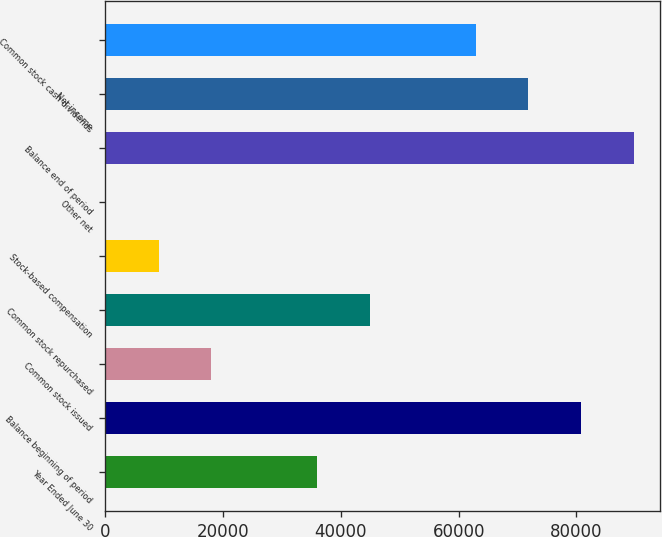Convert chart. <chart><loc_0><loc_0><loc_500><loc_500><bar_chart><fcel>Year Ended June 30<fcel>Balance beginning of period<fcel>Common stock issued<fcel>Common stock repurchased<fcel>Stock-based compensation<fcel>Other net<fcel>Balance end of period<fcel>Net income<fcel>Common stock cash dividends<nl><fcel>35951.4<fcel>80811.9<fcel>18007.2<fcel>44923.5<fcel>9035.1<fcel>63<fcel>89784<fcel>71839.8<fcel>62867.7<nl></chart> 